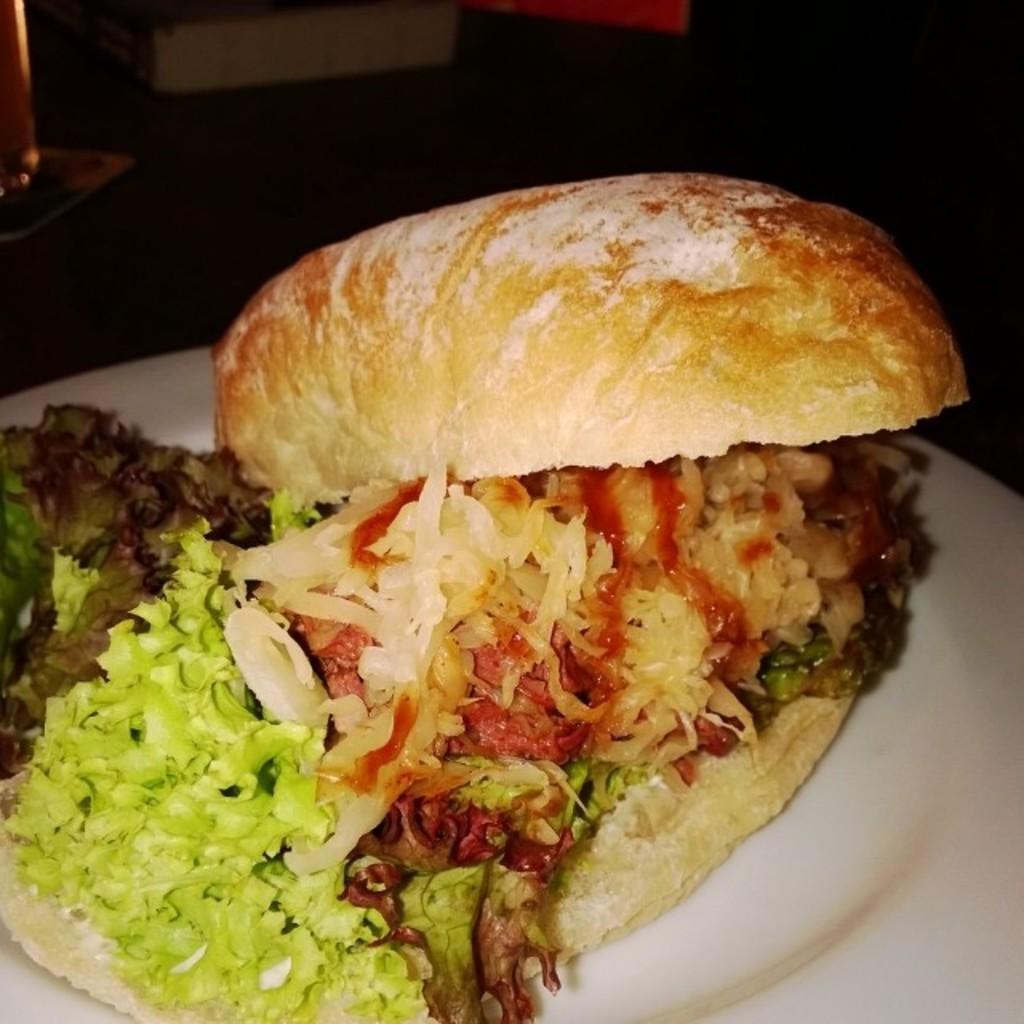Can you describe this image briefly? In this picture we can see bread, rice, cabbage, onions and other vegetables on the white plate. In the back we can see the table near to the wall. On the left there is a wash basin near to the door. 